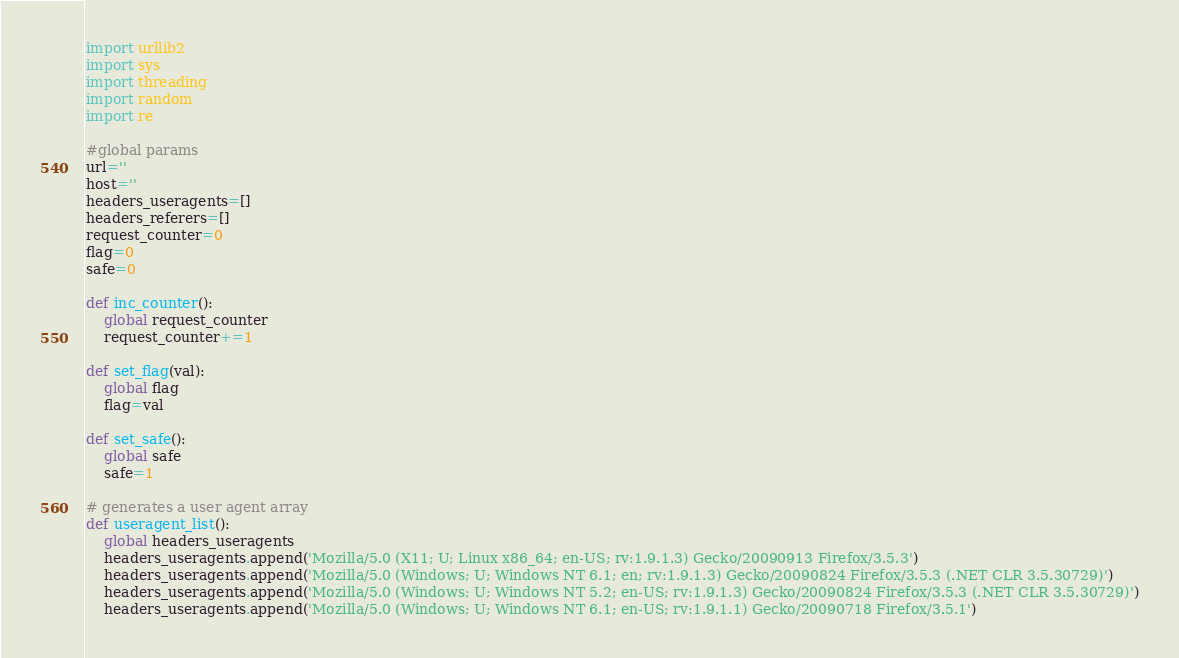<code> <loc_0><loc_0><loc_500><loc_500><_Python_>import urllib2
import sys
import threading
import random
import re

#global params
url=''
host=''
headers_useragents=[]
headers_referers=[]
request_counter=0
flag=0
safe=0

def inc_counter():
	global request_counter
	request_counter+=1

def set_flag(val):
	global flag
	flag=val

def set_safe():
	global safe
	safe=1
	
# generates a user agent array
def useragent_list():
	global headers_useragents
	headers_useragents.append('Mozilla/5.0 (X11; U; Linux x86_64; en-US; rv:1.9.1.3) Gecko/20090913 Firefox/3.5.3')
	headers_useragents.append('Mozilla/5.0 (Windows; U; Windows NT 6.1; en; rv:1.9.1.3) Gecko/20090824 Firefox/3.5.3 (.NET CLR 3.5.30729)')
	headers_useragents.append('Mozilla/5.0 (Windows; U; Windows NT 5.2; en-US; rv:1.9.1.3) Gecko/20090824 Firefox/3.5.3 (.NET CLR 3.5.30729)')
	headers_useragents.append('Mozilla/5.0 (Windows; U; Windows NT 6.1; en-US; rv:1.9.1.1) Gecko/20090718 Firefox/3.5.1')</code> 